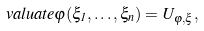<formula> <loc_0><loc_0><loc_500><loc_500>\ v a l u a t e { \varphi ( \xi _ { 1 } , \dots , \xi _ { n } ) } = U _ { \varphi , \xi } ,</formula> 